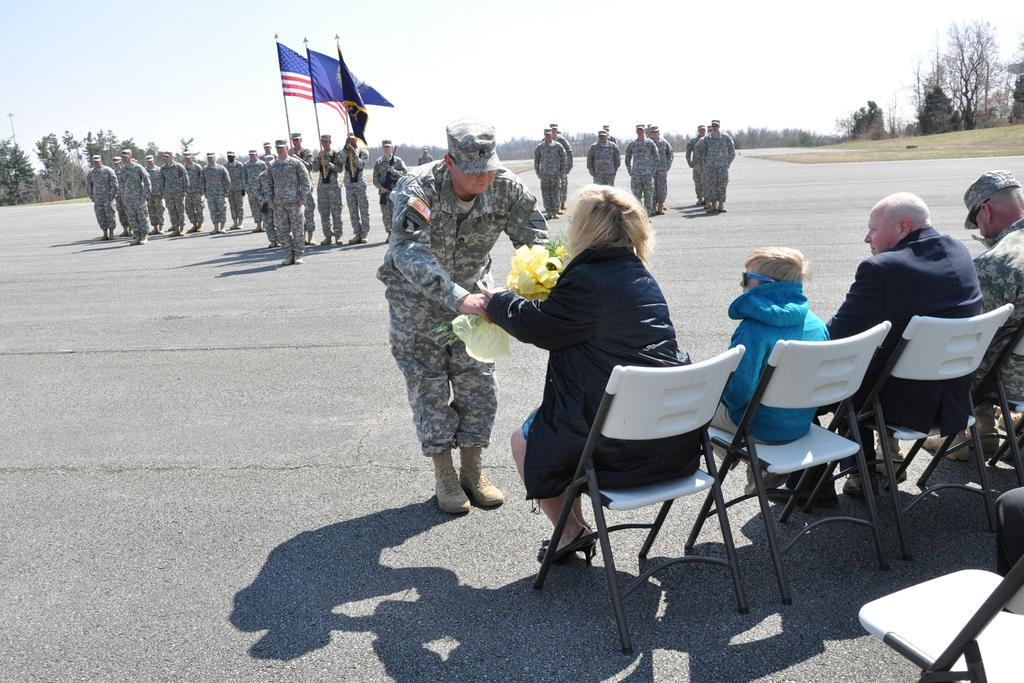What are the people in the image doing? The people in the image are standing and holding flags. Are there any other people in the image with a different posture? Yes, there are people seated on chairs in the image. What can be seen in the background of the image? Trees are visible around the area. What type of grass is growing on the error in the image? There is no error present in the image, and therefore no grass growing on it. 